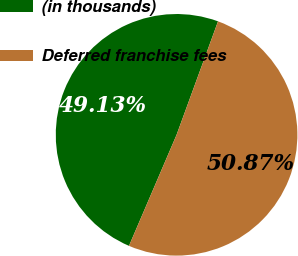Convert chart. <chart><loc_0><loc_0><loc_500><loc_500><pie_chart><fcel>(in thousands)<fcel>Deferred franchise fees<nl><fcel>49.13%<fcel>50.87%<nl></chart> 